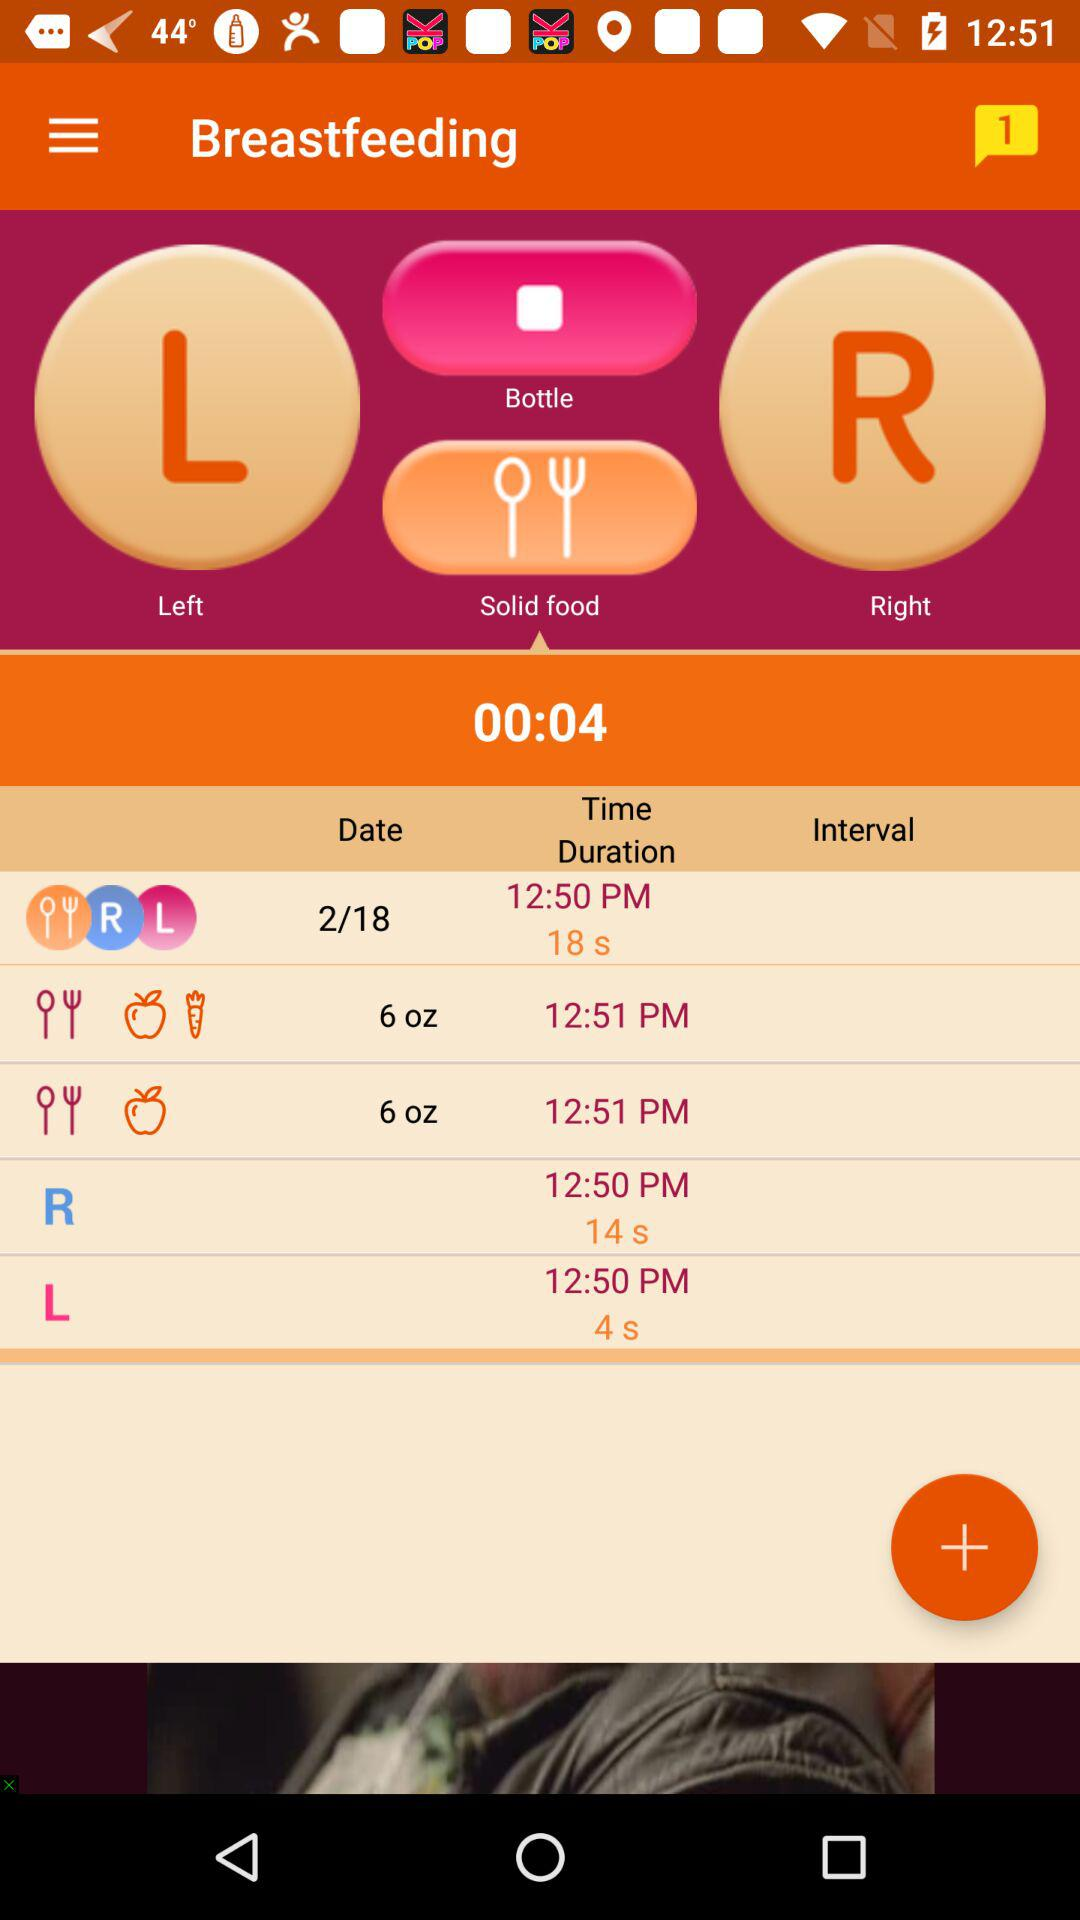How many notifications are pending? There is 1 notification pending. 